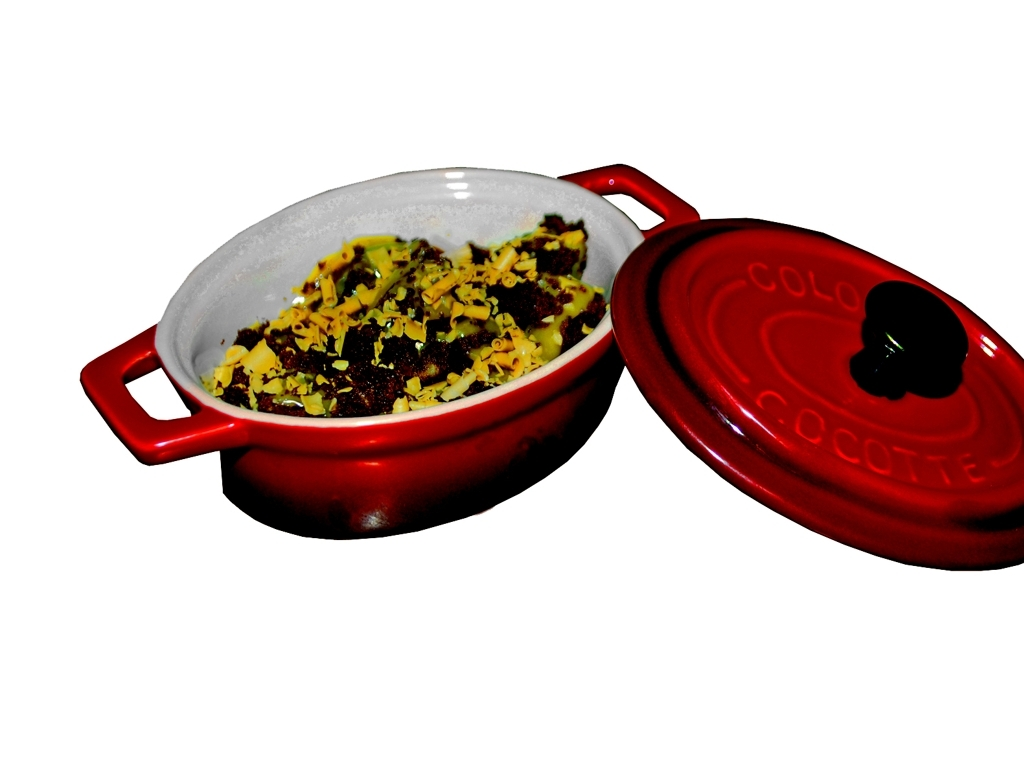Can you describe the design and brand of the cookware? The cookware in the image is a red ceramic dish with handles, which is likely a product from the brand 'COLO COCOTTE', as inscribed on the lid. This style is commonly associated with high-quality, durable cookware designed for baking and retaining heat. 